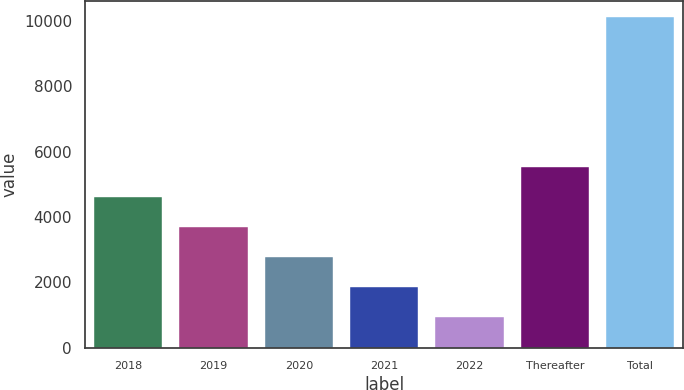Convert chart to OTSL. <chart><loc_0><loc_0><loc_500><loc_500><bar_chart><fcel>2018<fcel>2019<fcel>2020<fcel>2021<fcel>2022<fcel>Thereafter<fcel>Total<nl><fcel>4601.6<fcel>3684.2<fcel>2766.8<fcel>1849.4<fcel>932<fcel>5519<fcel>10106<nl></chart> 